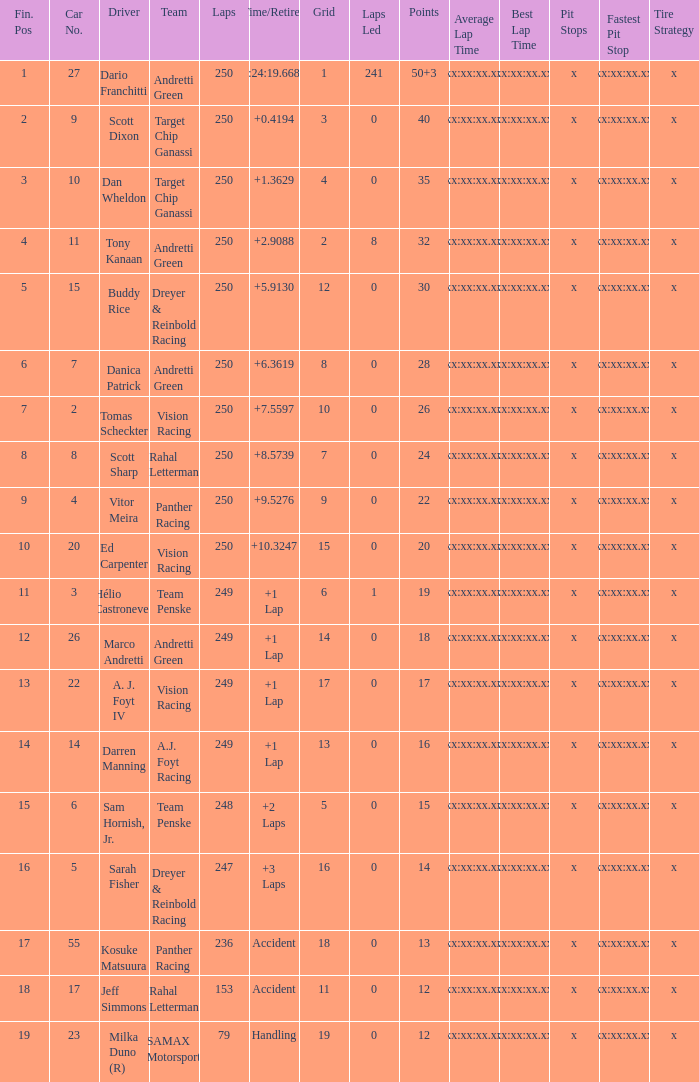Name the total number of fin pos for 12 points of accident 1.0. 